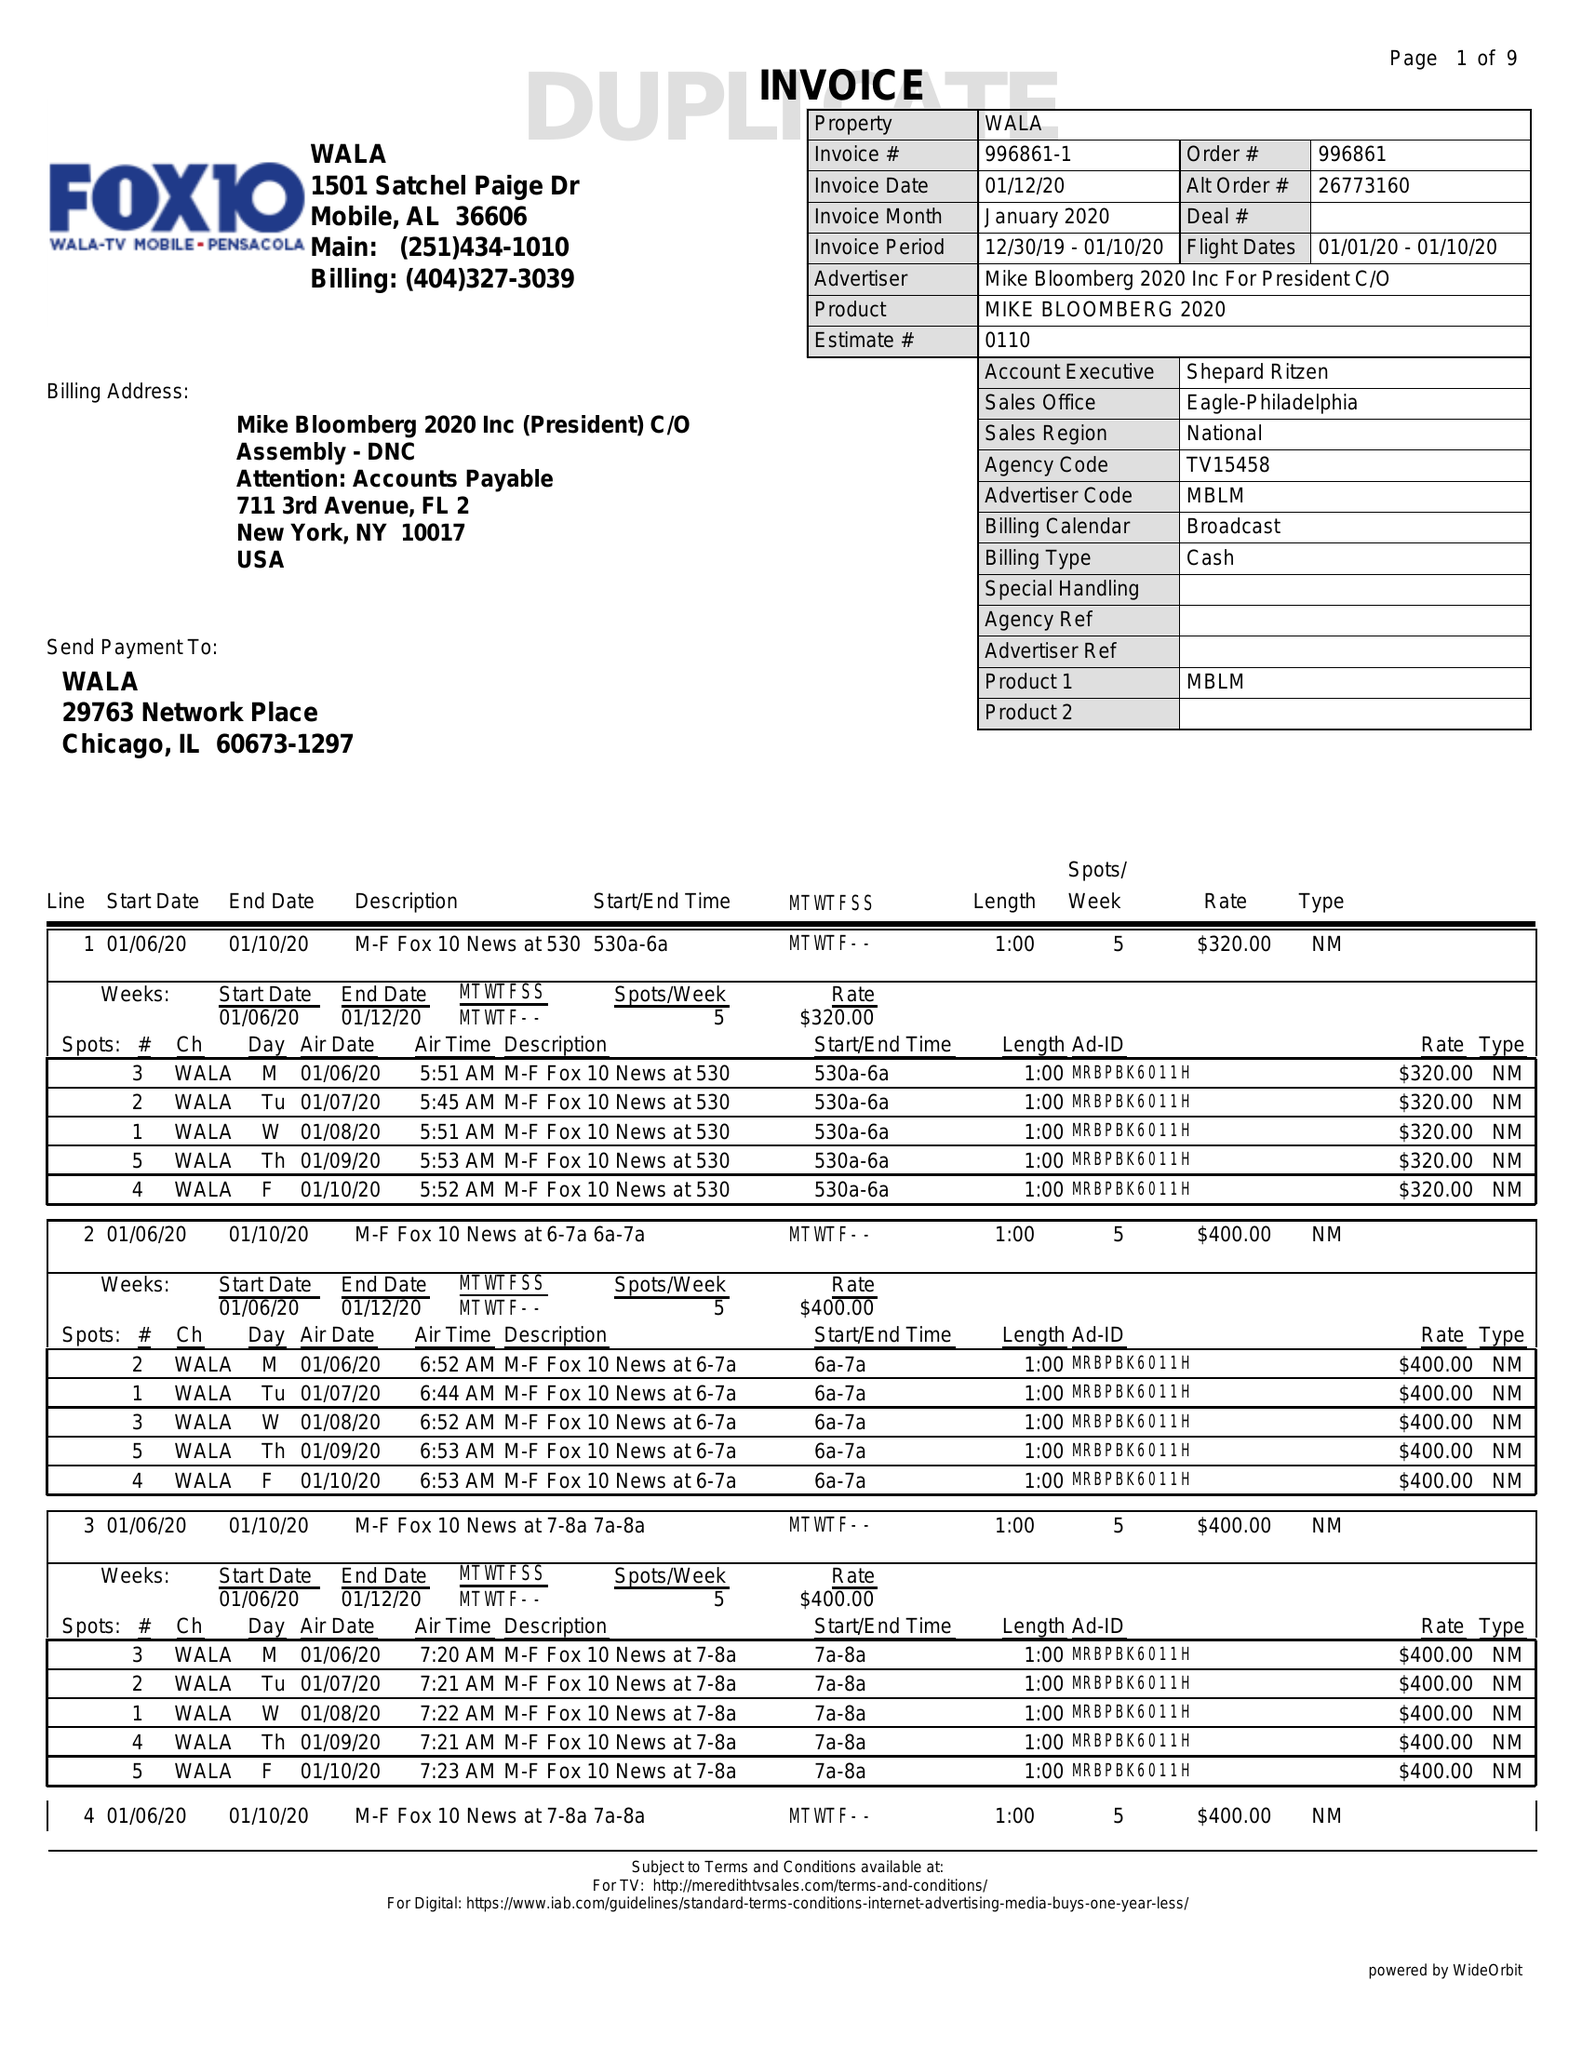What is the value for the contract_num?
Answer the question using a single word or phrase. 996861 